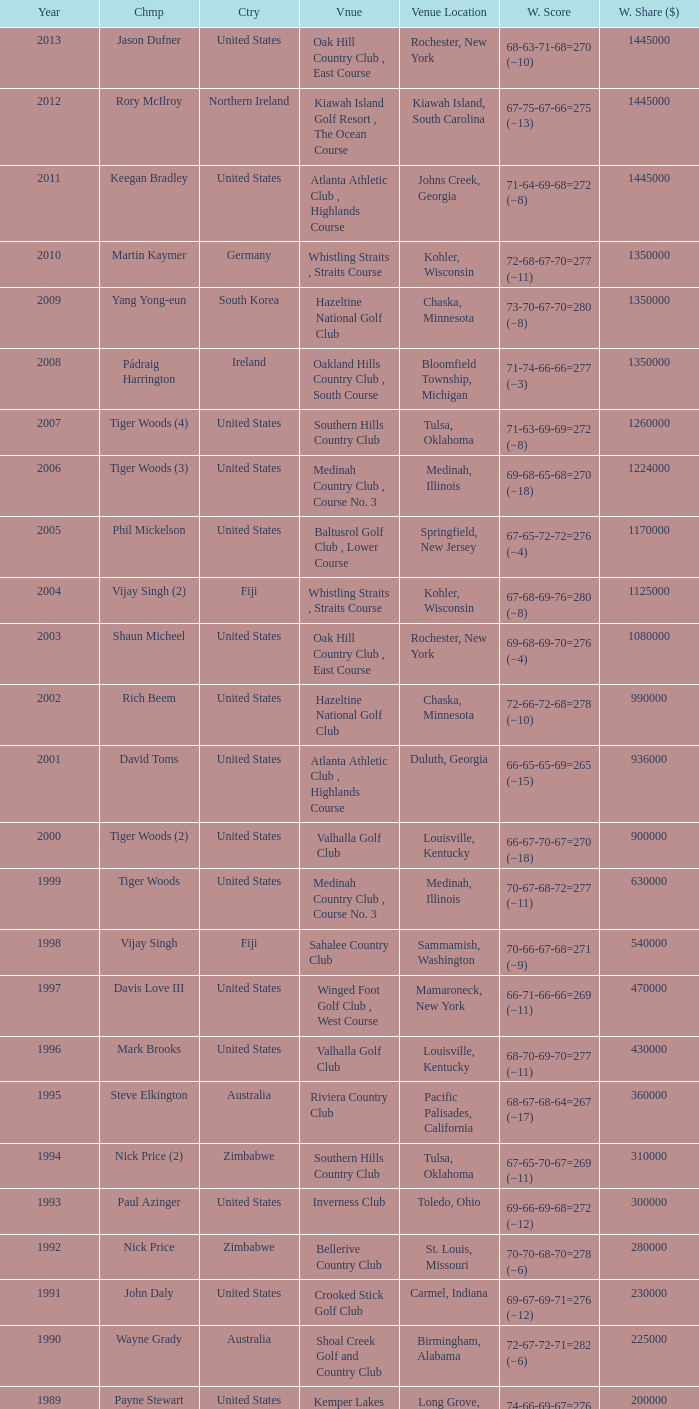In which location is the bellerive country club venue positioned? St. Louis, Missouri. 